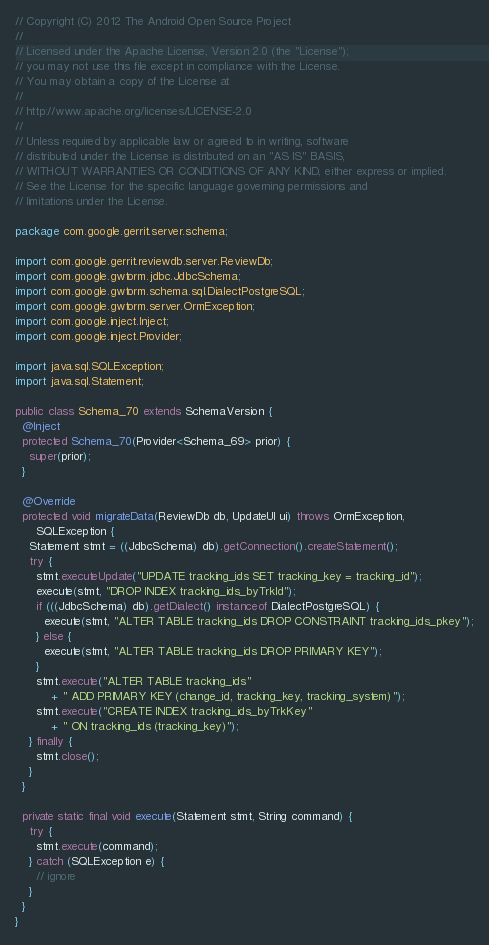<code> <loc_0><loc_0><loc_500><loc_500><_Java_>// Copyright (C) 2012 The Android Open Source Project
//
// Licensed under the Apache License, Version 2.0 (the "License");
// you may not use this file except in compliance with the License.
// You may obtain a copy of the License at
//
// http://www.apache.org/licenses/LICENSE-2.0
//
// Unless required by applicable law or agreed to in writing, software
// distributed under the License is distributed on an "AS IS" BASIS,
// WITHOUT WARRANTIES OR CONDITIONS OF ANY KIND, either express or implied.
// See the License for the specific language governing permissions and
// limitations under the License.

package com.google.gerrit.server.schema;

import com.google.gerrit.reviewdb.server.ReviewDb;
import com.google.gwtorm.jdbc.JdbcSchema;
import com.google.gwtorm.schema.sql.DialectPostgreSQL;
import com.google.gwtorm.server.OrmException;
import com.google.inject.Inject;
import com.google.inject.Provider;

import java.sql.SQLException;
import java.sql.Statement;

public class Schema_70 extends SchemaVersion {
  @Inject
  protected Schema_70(Provider<Schema_69> prior) {
    super(prior);
  }

  @Override
  protected void migrateData(ReviewDb db, UpdateUI ui) throws OrmException,
      SQLException {
    Statement stmt = ((JdbcSchema) db).getConnection().createStatement();
    try {
      stmt.executeUpdate("UPDATE tracking_ids SET tracking_key = tracking_id");
      execute(stmt, "DROP INDEX tracking_ids_byTrkId");
      if (((JdbcSchema) db).getDialect() instanceof DialectPostgreSQL) {
        execute(stmt, "ALTER TABLE tracking_ids DROP CONSTRAINT tracking_ids_pkey");
      } else {
        execute(stmt, "ALTER TABLE tracking_ids DROP PRIMARY KEY");
      }
      stmt.execute("ALTER TABLE tracking_ids"
          + " ADD PRIMARY KEY (change_id, tracking_key, tracking_system)");
      stmt.execute("CREATE INDEX tracking_ids_byTrkKey"
          + " ON tracking_ids (tracking_key)");
    } finally {
      stmt.close();
    }
  }

  private static final void execute(Statement stmt, String command) {
    try {
      stmt.execute(command);
    } catch (SQLException e) {
      // ignore
    }
  }
}
</code> 